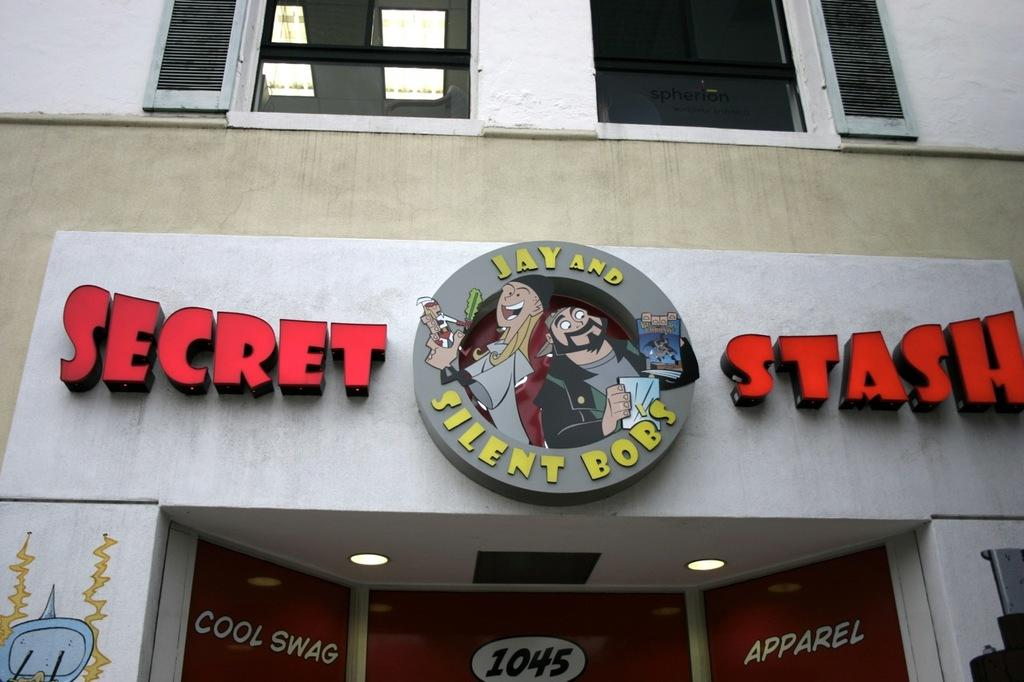<image>
Relay a brief, clear account of the picture shown. The outside of a store front that says Secret Stash also including two cartoon characters that says Jay and Silent Bob. 